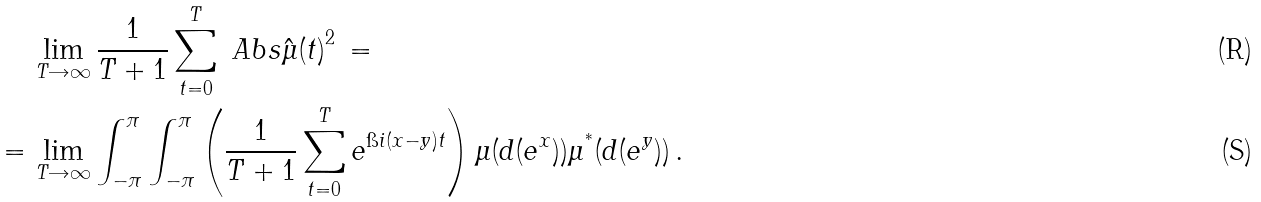<formula> <loc_0><loc_0><loc_500><loc_500>& \lim _ { T \rightarrow \infty } \frac { 1 } { T + 1 } \sum _ { t = 0 } ^ { T } \ A b s { \hat { \mu } ( t ) } ^ { 2 } \, = \\ = \, & \lim _ { T \rightarrow \infty } \int _ { - \pi } ^ { \pi } \int _ { - \pi } ^ { \pi } \left ( \frac { 1 } { T + 1 } \sum _ { t = 0 } ^ { T } e ^ { \i i ( x - y ) t } \right ) \mu ( d ( e ^ { x } ) ) \mu ^ { ^ { * } } ( d ( e ^ { y } ) ) \, .</formula> 